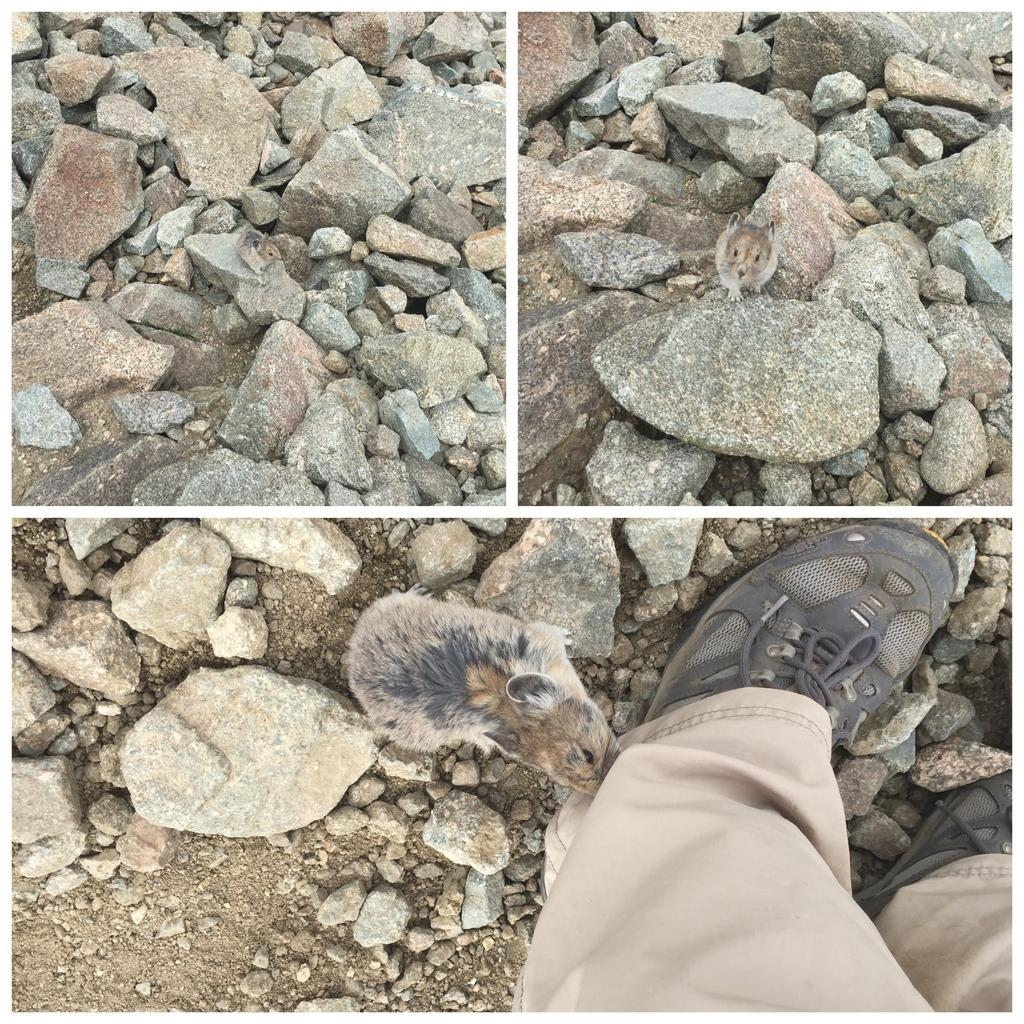What type of objects can be seen in the image? There are stones in the image. Are there any animals visible in the image? Yes, there are rats in the image. What else can be seen in the image besides stones and rats? There are persons' legs in the image. Where is the faucet located in the image? There is no faucet present in the image. What type of emotion is being expressed by the rats in the image? The image does not convey any emotions, and we cannot determine the rats' feelings from the image. 